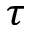Convert formula to latex. <formula><loc_0><loc_0><loc_500><loc_500>\tau</formula> 